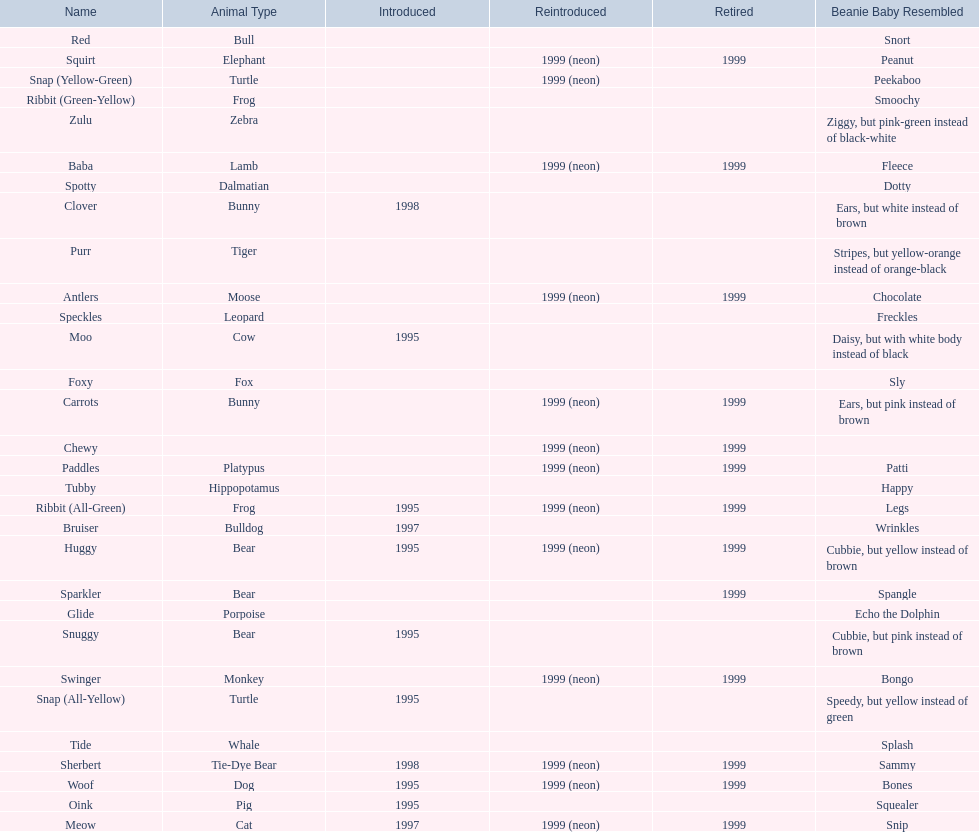What animals are pillow pals? Moose, Lamb, Bulldog, Bunny, Bunny, Fox, Porpoise, Bear, Cat, Cow, Pig, Platypus, Tiger, Bull, Frog, Frog, Tie-Dye Bear, Turtle, Turtle, Bear, Bear, Leopard, Dalmatian, Elephant, Monkey, Whale, Hippopotamus, Dog, Zebra. What is the name of the dalmatian? Spotty. 